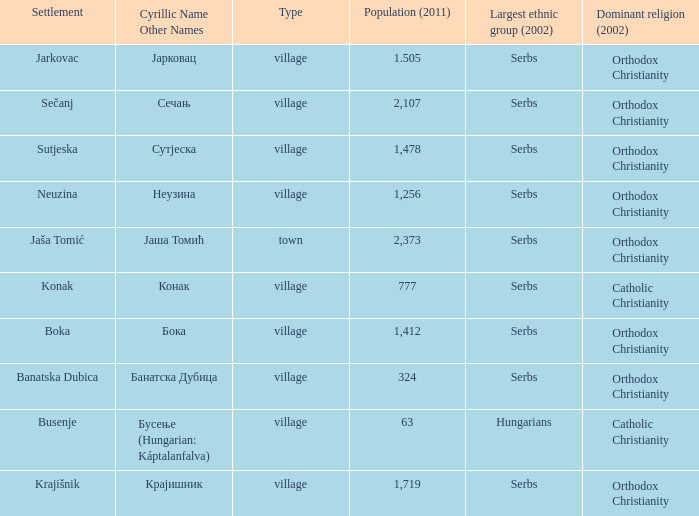The population is 2,107's dominant religion is? Orthodox Christianity. 